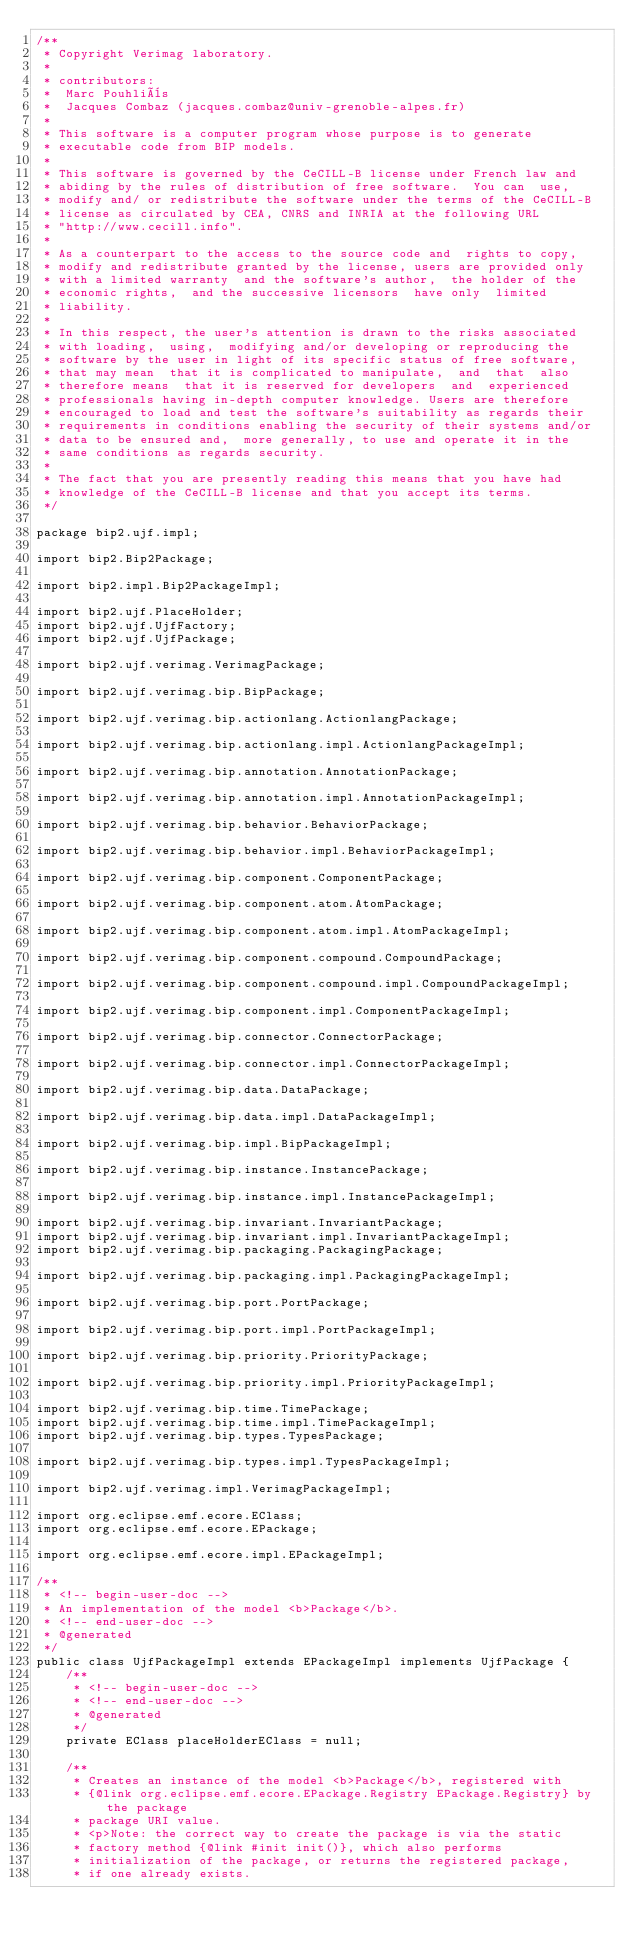<code> <loc_0><loc_0><loc_500><loc_500><_Java_>/**
 * Copyright Verimag laboratory.
 * 
 * contributors:
 *  Marc Pouhliès
 *  Jacques Combaz (jacques.combaz@univ-grenoble-alpes.fr)
 * 
 * This software is a computer program whose purpose is to generate
 * executable code from BIP models.
 * 
 * This software is governed by the CeCILL-B license under French law and
 * abiding by the rules of distribution of free software.  You can  use, 
 * modify and/ or redistribute the software under the terms of the CeCILL-B
 * license as circulated by CEA, CNRS and INRIA at the following URL
 * "http://www.cecill.info".
 * 
 * As a counterpart to the access to the source code and  rights to copy,
 * modify and redistribute granted by the license, users are provided only
 * with a limited warranty  and the software's author,  the holder of the
 * economic rights,  and the successive licensors  have only  limited
 * liability.
 *
 * In this respect, the user's attention is drawn to the risks associated
 * with loading,  using,  modifying and/or developing or reproducing the
 * software by the user in light of its specific status of free software,
 * that may mean  that it is complicated to manipulate,  and  that  also
 * therefore means  that it is reserved for developers  and  experienced
 * professionals having in-depth computer knowledge. Users are therefore
 * encouraged to load and test the software's suitability as regards their
 * requirements in conditions enabling the security of their systems and/or 
 * data to be ensured and,  more generally, to use and operate it in the 
 * same conditions as regards security.
 * 
 * The fact that you are presently reading this means that you have had
 * knowledge of the CeCILL-B license and that you accept its terms.
 */

package bip2.ujf.impl;

import bip2.Bip2Package;

import bip2.impl.Bip2PackageImpl;

import bip2.ujf.PlaceHolder;
import bip2.ujf.UjfFactory;
import bip2.ujf.UjfPackage;

import bip2.ujf.verimag.VerimagPackage;

import bip2.ujf.verimag.bip.BipPackage;

import bip2.ujf.verimag.bip.actionlang.ActionlangPackage;

import bip2.ujf.verimag.bip.actionlang.impl.ActionlangPackageImpl;

import bip2.ujf.verimag.bip.annotation.AnnotationPackage;

import bip2.ujf.verimag.bip.annotation.impl.AnnotationPackageImpl;

import bip2.ujf.verimag.bip.behavior.BehaviorPackage;

import bip2.ujf.verimag.bip.behavior.impl.BehaviorPackageImpl;

import bip2.ujf.verimag.bip.component.ComponentPackage;

import bip2.ujf.verimag.bip.component.atom.AtomPackage;

import bip2.ujf.verimag.bip.component.atom.impl.AtomPackageImpl;

import bip2.ujf.verimag.bip.component.compound.CompoundPackage;

import bip2.ujf.verimag.bip.component.compound.impl.CompoundPackageImpl;

import bip2.ujf.verimag.bip.component.impl.ComponentPackageImpl;

import bip2.ujf.verimag.bip.connector.ConnectorPackage;

import bip2.ujf.verimag.bip.connector.impl.ConnectorPackageImpl;

import bip2.ujf.verimag.bip.data.DataPackage;

import bip2.ujf.verimag.bip.data.impl.DataPackageImpl;

import bip2.ujf.verimag.bip.impl.BipPackageImpl;

import bip2.ujf.verimag.bip.instance.InstancePackage;

import bip2.ujf.verimag.bip.instance.impl.InstancePackageImpl;

import bip2.ujf.verimag.bip.invariant.InvariantPackage;
import bip2.ujf.verimag.bip.invariant.impl.InvariantPackageImpl;
import bip2.ujf.verimag.bip.packaging.PackagingPackage;

import bip2.ujf.verimag.bip.packaging.impl.PackagingPackageImpl;

import bip2.ujf.verimag.bip.port.PortPackage;

import bip2.ujf.verimag.bip.port.impl.PortPackageImpl;

import bip2.ujf.verimag.bip.priority.PriorityPackage;

import bip2.ujf.verimag.bip.priority.impl.PriorityPackageImpl;

import bip2.ujf.verimag.bip.time.TimePackage;
import bip2.ujf.verimag.bip.time.impl.TimePackageImpl;
import bip2.ujf.verimag.bip.types.TypesPackage;

import bip2.ujf.verimag.bip.types.impl.TypesPackageImpl;

import bip2.ujf.verimag.impl.VerimagPackageImpl;

import org.eclipse.emf.ecore.EClass;
import org.eclipse.emf.ecore.EPackage;

import org.eclipse.emf.ecore.impl.EPackageImpl;

/**
 * <!-- begin-user-doc -->
 * An implementation of the model <b>Package</b>.
 * <!-- end-user-doc -->
 * @generated
 */
public class UjfPackageImpl extends EPackageImpl implements UjfPackage {
    /**
     * <!-- begin-user-doc -->
     * <!-- end-user-doc -->
     * @generated
     */
    private EClass placeHolderEClass = null;

    /**
     * Creates an instance of the model <b>Package</b>, registered with
     * {@link org.eclipse.emf.ecore.EPackage.Registry EPackage.Registry} by the package
     * package URI value.
     * <p>Note: the correct way to create the package is via the static
     * factory method {@link #init init()}, which also performs
     * initialization of the package, or returns the registered package,
     * if one already exists.</code> 